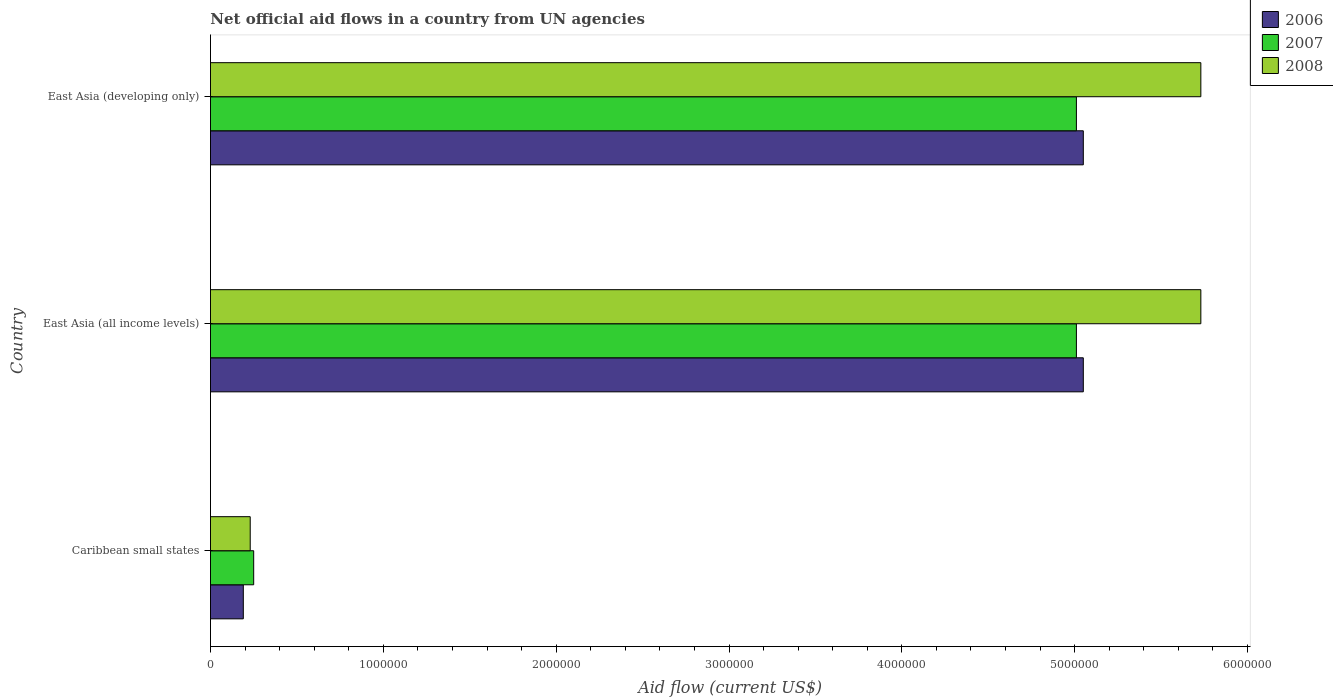Are the number of bars on each tick of the Y-axis equal?
Offer a very short reply. Yes. What is the label of the 2nd group of bars from the top?
Offer a very short reply. East Asia (all income levels). What is the net official aid flow in 2007 in East Asia (all income levels)?
Ensure brevity in your answer.  5.01e+06. Across all countries, what is the maximum net official aid flow in 2008?
Give a very brief answer. 5.73e+06. Across all countries, what is the minimum net official aid flow in 2008?
Your answer should be very brief. 2.30e+05. In which country was the net official aid flow in 2007 maximum?
Your response must be concise. East Asia (all income levels). In which country was the net official aid flow in 2008 minimum?
Offer a very short reply. Caribbean small states. What is the total net official aid flow in 2008 in the graph?
Ensure brevity in your answer.  1.17e+07. What is the difference between the net official aid flow in 2007 in Caribbean small states and that in East Asia (developing only)?
Ensure brevity in your answer.  -4.76e+06. What is the difference between the net official aid flow in 2008 in East Asia (all income levels) and the net official aid flow in 2007 in East Asia (developing only)?
Offer a terse response. 7.20e+05. What is the average net official aid flow in 2006 per country?
Offer a terse response. 3.43e+06. What is the difference between the net official aid flow in 2006 and net official aid flow in 2008 in East Asia (all income levels)?
Give a very brief answer. -6.80e+05. What is the ratio of the net official aid flow in 2008 in East Asia (all income levels) to that in East Asia (developing only)?
Keep it short and to the point. 1. Is the net official aid flow in 2008 in Caribbean small states less than that in East Asia (all income levels)?
Make the answer very short. Yes. Is the difference between the net official aid flow in 2006 in Caribbean small states and East Asia (developing only) greater than the difference between the net official aid flow in 2008 in Caribbean small states and East Asia (developing only)?
Offer a terse response. Yes. What is the difference between the highest and the second highest net official aid flow in 2006?
Offer a terse response. 0. What is the difference between the highest and the lowest net official aid flow in 2007?
Offer a terse response. 4.76e+06. Is the sum of the net official aid flow in 2006 in Caribbean small states and East Asia (all income levels) greater than the maximum net official aid flow in 2008 across all countries?
Ensure brevity in your answer.  No. What does the 1st bar from the top in East Asia (developing only) represents?
Offer a very short reply. 2008. What does the 3rd bar from the bottom in East Asia (developing only) represents?
Your answer should be very brief. 2008. How many bars are there?
Provide a short and direct response. 9. Are all the bars in the graph horizontal?
Ensure brevity in your answer.  Yes. How many countries are there in the graph?
Your answer should be very brief. 3. Are the values on the major ticks of X-axis written in scientific E-notation?
Offer a very short reply. No. Does the graph contain grids?
Keep it short and to the point. No. Where does the legend appear in the graph?
Your answer should be compact. Top right. What is the title of the graph?
Give a very brief answer. Net official aid flows in a country from UN agencies. Does "2010" appear as one of the legend labels in the graph?
Make the answer very short. No. What is the label or title of the Y-axis?
Provide a succinct answer. Country. What is the Aid flow (current US$) of 2007 in Caribbean small states?
Keep it short and to the point. 2.50e+05. What is the Aid flow (current US$) of 2006 in East Asia (all income levels)?
Your answer should be compact. 5.05e+06. What is the Aid flow (current US$) of 2007 in East Asia (all income levels)?
Ensure brevity in your answer.  5.01e+06. What is the Aid flow (current US$) of 2008 in East Asia (all income levels)?
Your answer should be compact. 5.73e+06. What is the Aid flow (current US$) of 2006 in East Asia (developing only)?
Give a very brief answer. 5.05e+06. What is the Aid flow (current US$) in 2007 in East Asia (developing only)?
Offer a terse response. 5.01e+06. What is the Aid flow (current US$) of 2008 in East Asia (developing only)?
Offer a terse response. 5.73e+06. Across all countries, what is the maximum Aid flow (current US$) in 2006?
Offer a very short reply. 5.05e+06. Across all countries, what is the maximum Aid flow (current US$) in 2007?
Ensure brevity in your answer.  5.01e+06. Across all countries, what is the maximum Aid flow (current US$) in 2008?
Provide a succinct answer. 5.73e+06. Across all countries, what is the minimum Aid flow (current US$) in 2007?
Make the answer very short. 2.50e+05. What is the total Aid flow (current US$) of 2006 in the graph?
Ensure brevity in your answer.  1.03e+07. What is the total Aid flow (current US$) in 2007 in the graph?
Your answer should be very brief. 1.03e+07. What is the total Aid flow (current US$) in 2008 in the graph?
Provide a short and direct response. 1.17e+07. What is the difference between the Aid flow (current US$) in 2006 in Caribbean small states and that in East Asia (all income levels)?
Your answer should be compact. -4.86e+06. What is the difference between the Aid flow (current US$) in 2007 in Caribbean small states and that in East Asia (all income levels)?
Keep it short and to the point. -4.76e+06. What is the difference between the Aid flow (current US$) in 2008 in Caribbean small states and that in East Asia (all income levels)?
Offer a terse response. -5.50e+06. What is the difference between the Aid flow (current US$) of 2006 in Caribbean small states and that in East Asia (developing only)?
Your response must be concise. -4.86e+06. What is the difference between the Aid flow (current US$) of 2007 in Caribbean small states and that in East Asia (developing only)?
Provide a succinct answer. -4.76e+06. What is the difference between the Aid flow (current US$) in 2008 in Caribbean small states and that in East Asia (developing only)?
Your response must be concise. -5.50e+06. What is the difference between the Aid flow (current US$) in 2007 in East Asia (all income levels) and that in East Asia (developing only)?
Your response must be concise. 0. What is the difference between the Aid flow (current US$) in 2008 in East Asia (all income levels) and that in East Asia (developing only)?
Ensure brevity in your answer.  0. What is the difference between the Aid flow (current US$) of 2006 in Caribbean small states and the Aid flow (current US$) of 2007 in East Asia (all income levels)?
Offer a terse response. -4.82e+06. What is the difference between the Aid flow (current US$) in 2006 in Caribbean small states and the Aid flow (current US$) in 2008 in East Asia (all income levels)?
Give a very brief answer. -5.54e+06. What is the difference between the Aid flow (current US$) of 2007 in Caribbean small states and the Aid flow (current US$) of 2008 in East Asia (all income levels)?
Provide a short and direct response. -5.48e+06. What is the difference between the Aid flow (current US$) in 2006 in Caribbean small states and the Aid flow (current US$) in 2007 in East Asia (developing only)?
Keep it short and to the point. -4.82e+06. What is the difference between the Aid flow (current US$) in 2006 in Caribbean small states and the Aid flow (current US$) in 2008 in East Asia (developing only)?
Give a very brief answer. -5.54e+06. What is the difference between the Aid flow (current US$) of 2007 in Caribbean small states and the Aid flow (current US$) of 2008 in East Asia (developing only)?
Ensure brevity in your answer.  -5.48e+06. What is the difference between the Aid flow (current US$) in 2006 in East Asia (all income levels) and the Aid flow (current US$) in 2007 in East Asia (developing only)?
Provide a succinct answer. 4.00e+04. What is the difference between the Aid flow (current US$) of 2006 in East Asia (all income levels) and the Aid flow (current US$) of 2008 in East Asia (developing only)?
Offer a very short reply. -6.80e+05. What is the difference between the Aid flow (current US$) in 2007 in East Asia (all income levels) and the Aid flow (current US$) in 2008 in East Asia (developing only)?
Offer a terse response. -7.20e+05. What is the average Aid flow (current US$) of 2006 per country?
Ensure brevity in your answer.  3.43e+06. What is the average Aid flow (current US$) in 2007 per country?
Your answer should be compact. 3.42e+06. What is the average Aid flow (current US$) of 2008 per country?
Ensure brevity in your answer.  3.90e+06. What is the difference between the Aid flow (current US$) in 2006 and Aid flow (current US$) in 2007 in Caribbean small states?
Keep it short and to the point. -6.00e+04. What is the difference between the Aid flow (current US$) of 2006 and Aid flow (current US$) of 2007 in East Asia (all income levels)?
Make the answer very short. 4.00e+04. What is the difference between the Aid flow (current US$) in 2006 and Aid flow (current US$) in 2008 in East Asia (all income levels)?
Offer a terse response. -6.80e+05. What is the difference between the Aid flow (current US$) of 2007 and Aid flow (current US$) of 2008 in East Asia (all income levels)?
Your response must be concise. -7.20e+05. What is the difference between the Aid flow (current US$) in 2006 and Aid flow (current US$) in 2007 in East Asia (developing only)?
Make the answer very short. 4.00e+04. What is the difference between the Aid flow (current US$) of 2006 and Aid flow (current US$) of 2008 in East Asia (developing only)?
Make the answer very short. -6.80e+05. What is the difference between the Aid flow (current US$) of 2007 and Aid flow (current US$) of 2008 in East Asia (developing only)?
Provide a short and direct response. -7.20e+05. What is the ratio of the Aid flow (current US$) in 2006 in Caribbean small states to that in East Asia (all income levels)?
Your response must be concise. 0.04. What is the ratio of the Aid flow (current US$) of 2007 in Caribbean small states to that in East Asia (all income levels)?
Ensure brevity in your answer.  0.05. What is the ratio of the Aid flow (current US$) in 2008 in Caribbean small states to that in East Asia (all income levels)?
Provide a short and direct response. 0.04. What is the ratio of the Aid flow (current US$) of 2006 in Caribbean small states to that in East Asia (developing only)?
Ensure brevity in your answer.  0.04. What is the ratio of the Aid flow (current US$) of 2007 in Caribbean small states to that in East Asia (developing only)?
Keep it short and to the point. 0.05. What is the ratio of the Aid flow (current US$) in 2008 in Caribbean small states to that in East Asia (developing only)?
Your response must be concise. 0.04. What is the ratio of the Aid flow (current US$) of 2006 in East Asia (all income levels) to that in East Asia (developing only)?
Give a very brief answer. 1. What is the ratio of the Aid flow (current US$) of 2008 in East Asia (all income levels) to that in East Asia (developing only)?
Your answer should be very brief. 1. What is the difference between the highest and the second highest Aid flow (current US$) in 2008?
Your response must be concise. 0. What is the difference between the highest and the lowest Aid flow (current US$) of 2006?
Ensure brevity in your answer.  4.86e+06. What is the difference between the highest and the lowest Aid flow (current US$) in 2007?
Keep it short and to the point. 4.76e+06. What is the difference between the highest and the lowest Aid flow (current US$) in 2008?
Your answer should be compact. 5.50e+06. 